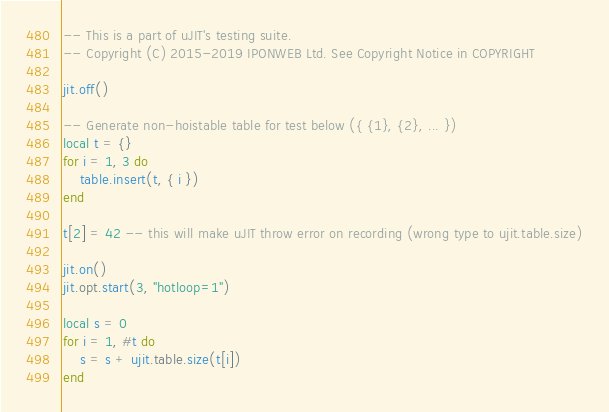<code> <loc_0><loc_0><loc_500><loc_500><_Lua_>-- This is a part of uJIT's testing suite.
-- Copyright (C) 2015-2019 IPONWEB Ltd. See Copyright Notice in COPYRIGHT

jit.off()

-- Generate non-hoistable table for test below ({ {1}, {2}, ... })
local t = {}
for i = 1, 3 do
    table.insert(t, { i })
end

t[2] = 42 -- this will make uJIT throw error on recording (wrong type to ujit.table.size)

jit.on()
jit.opt.start(3, "hotloop=1")

local s = 0
for i = 1, #t do
    s = s + ujit.table.size(t[i])
end
</code> 